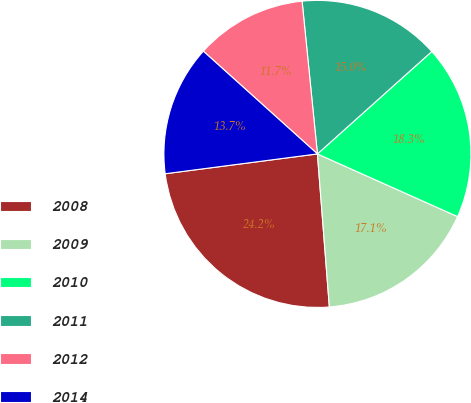Convert chart. <chart><loc_0><loc_0><loc_500><loc_500><pie_chart><fcel>2008<fcel>2009<fcel>2010<fcel>2011<fcel>2012<fcel>2014<nl><fcel>24.18%<fcel>17.07%<fcel>18.32%<fcel>14.97%<fcel>11.74%<fcel>13.73%<nl></chart> 